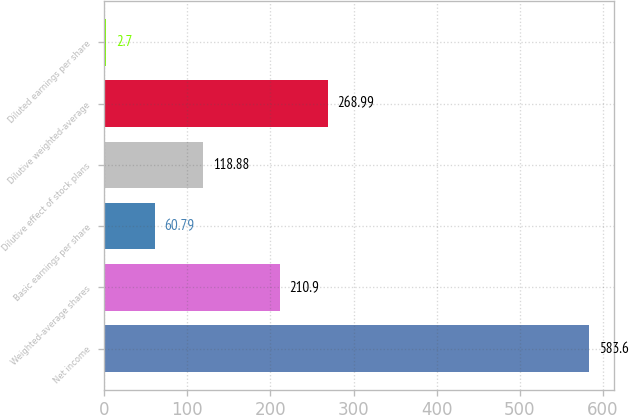Convert chart. <chart><loc_0><loc_0><loc_500><loc_500><bar_chart><fcel>Net income<fcel>Weighted-average shares<fcel>Basic earnings per share<fcel>Dilutive effect of stock plans<fcel>Dilutive weighted-average<fcel>Diluted earnings per share<nl><fcel>583.6<fcel>210.9<fcel>60.79<fcel>118.88<fcel>268.99<fcel>2.7<nl></chart> 